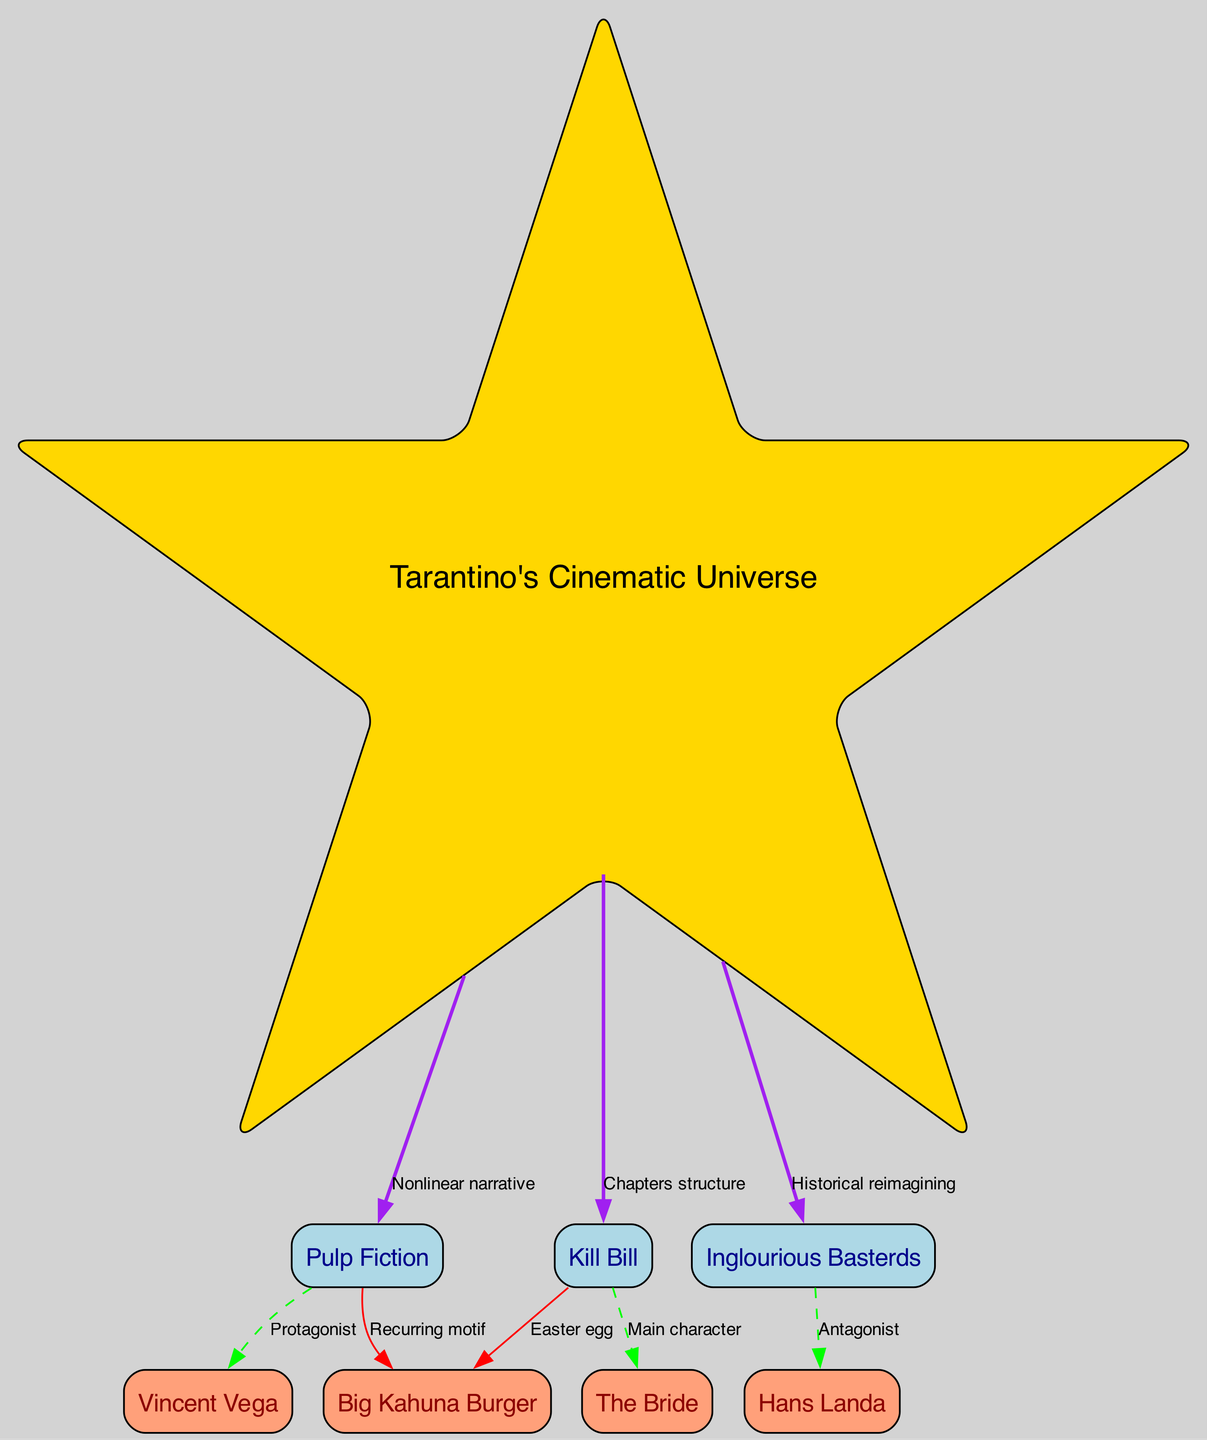What is the central hub of the diagram? The diagram indicates that "Tarantino's Cinematic Universe" serves as the main hub, as it connects all other films represented as nodes. It has a distinct label and is the first node associated with multiple relationships.
Answer: Tarantino's Cinematic Universe How many nodes are there in total? By counting all the nodes outlined in the data, we find a total of eight distinct nodes representing various films and characters in the universe.
Answer: 8 Which film has a protagonist labeled in the diagram? The diagram specifies that "Pulp Fiction" includes "Vincent Vega" as its protagonist, indicated by the labeled edge connecting them.
Answer: Vincent Vega What type of narrative is used in "Pulp Fiction"? The relationship from "Tarantino's Cinematic Universe" to "Pulp Fiction" is labeled as "Nonlinear narrative," indicating the narrative style present in the film.
Answer: Nonlinear narrative Which character from "Inglourious Basterds" is an antagonist? The diagram highlights that "Hans Landa" is labeled as the antagonist of "Inglourious Basterds," creating a direct connection from the film to him.
Answer: Hans Landa What recurring motif is connected to both "Pulp Fiction" and "Kill Bill"? The relationship to the fictional fast-food chain "Big Kahuna Burger" appears in both "Pulp Fiction" as a recurring motif and in "Kill Bill" as an Easter egg, emphasizing its importance in Tarantino's work.
Answer: Big Kahuna Burger Which film has a character seeking vengeance? "Kill Bill" features "The Bride" as its main character, who is described as an assassin seeking vengeance, forming the core of the film's plot.
Answer: The Bride How are "Kill Bill" and "Pulp Fiction" connected? Both films are shown to have a relationship with "Big Kahuna Burger," highlighting its role in the narrative, specifically as a motif in "Pulp Fiction" and an Easter egg in "Kill Bill."
Answer: Big Kahuna Burger How many edges are there in the diagram? By counting the connections (relationships) drawn between the nodes, it can be determined that there are a total of seven edges illustrating interactions between the films and characters.
Answer: 7 